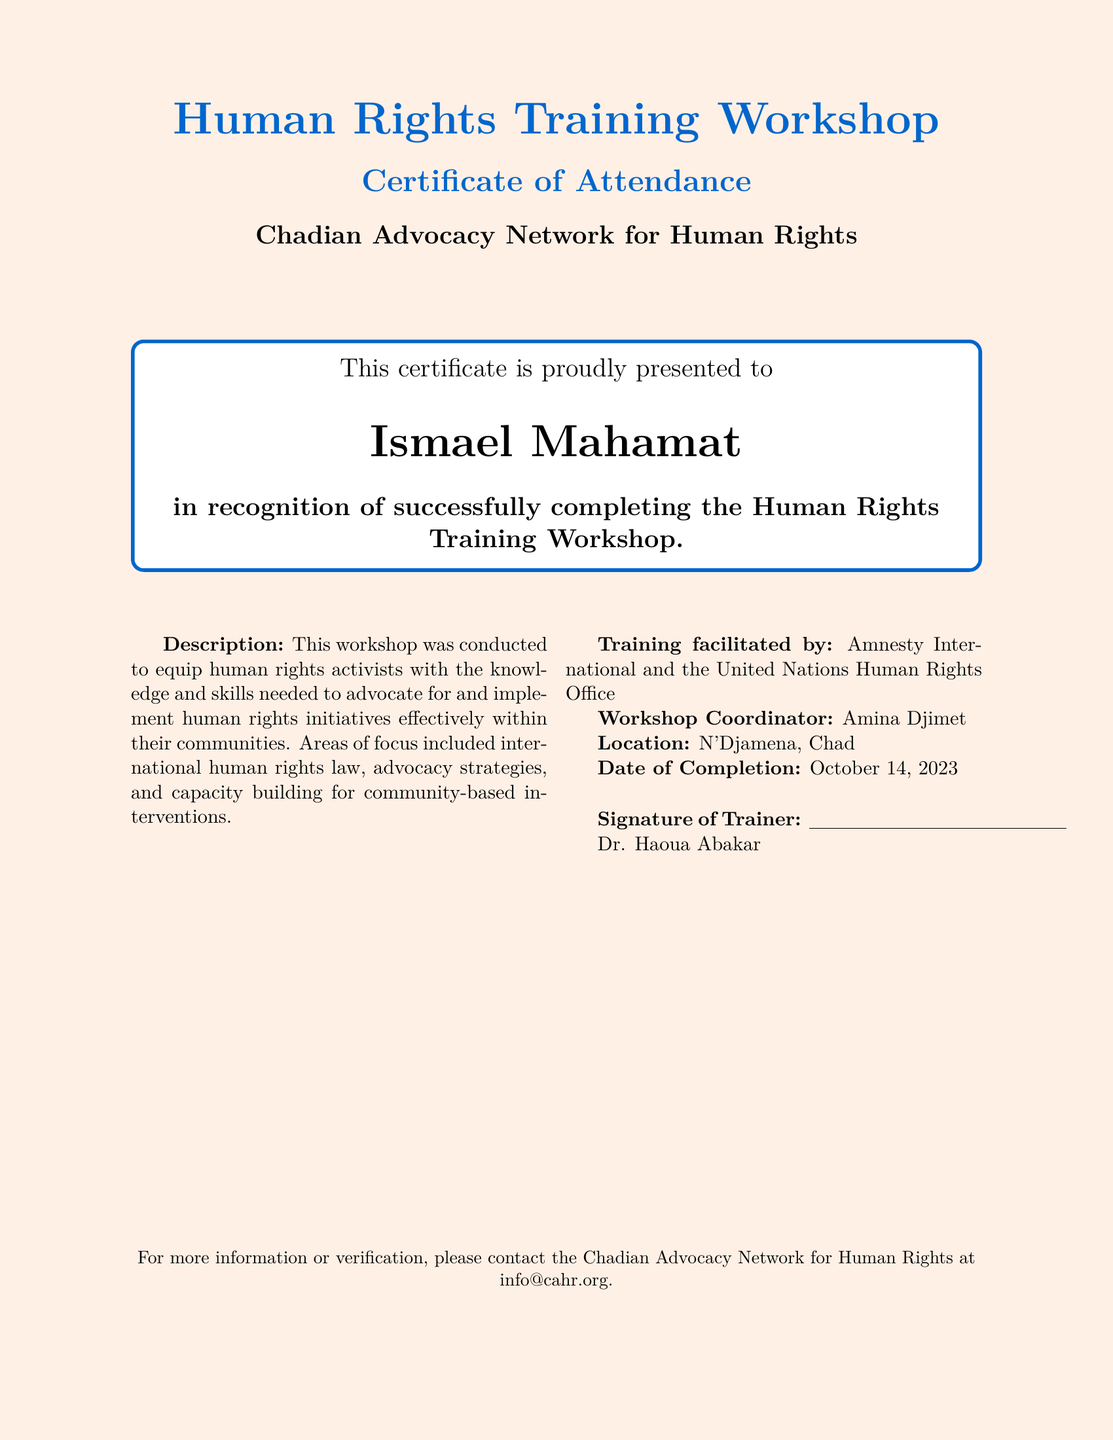What is the name of the participant? The participant's name is prominently displayed in the document as the individual who completed the workshop.
Answer: Ismael Mahamat What is the date of completion? The completion date is stated clearly toward the end of the document.
Answer: October 14, 2023 Who facilitated the training? The facilitators are named in the document, highlighting the organizations involved in the training.
Answer: Amnesty International and the United Nations Human Rights Office What is the title of the workshop? The title is featured prominently at the top of the document, summarizing the focus of the training.
Answer: Human Rights Training Workshop Who is the Workshop Coordinator? The document identifies the person responsible for organizing the workshop in one of the sections.
Answer: Amina Djimet What is the location of the workshop? The location where the workshop took place is specified in the document.
Answer: N'Djamena, Chad What is described in the training description? The description summarizes the skills and knowledge the workshop aimed to provide human rights activists.
Answer: Advocacy for human rights initiatives What type of document is this? The type of document can be inferred from its purpose and content, which is to certify attendance.
Answer: Certificate of Attendance 